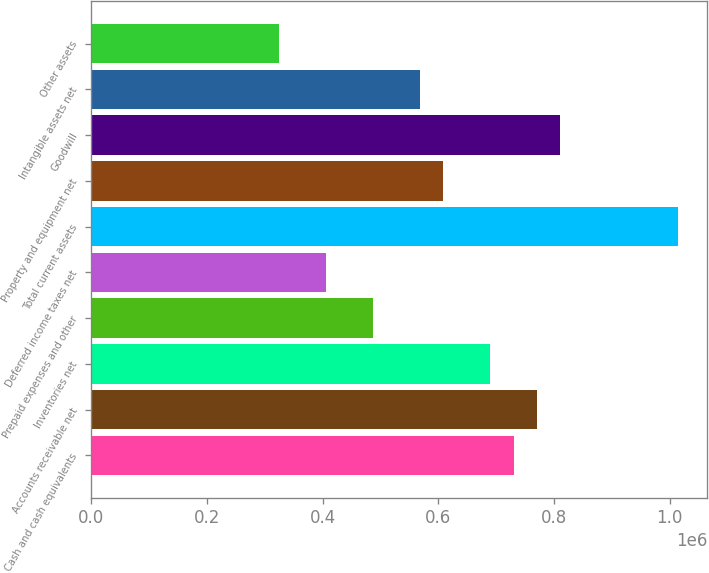Convert chart to OTSL. <chart><loc_0><loc_0><loc_500><loc_500><bar_chart><fcel>Cash and cash equivalents<fcel>Accounts receivable net<fcel>Inventories net<fcel>Prepaid expenses and other<fcel>Deferred income taxes net<fcel>Total current assets<fcel>Property and equipment net<fcel>Goodwill<fcel>Intangible assets net<fcel>Other assets<nl><fcel>729924<fcel>770472<fcel>689375<fcel>486634<fcel>405538<fcel>1.01376e+06<fcel>608279<fcel>811020<fcel>567731<fcel>324442<nl></chart> 